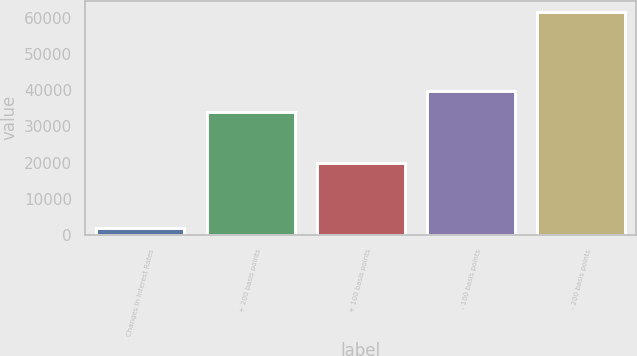Convert chart to OTSL. <chart><loc_0><loc_0><loc_500><loc_500><bar_chart><fcel>Changes in Interest Rates<fcel>+ 200 basis points<fcel>+ 100 basis points<fcel>- 100 basis points<fcel>- 200 basis points<nl><fcel>2009<fcel>33974<fcel>19989<fcel>39946<fcel>61729<nl></chart> 